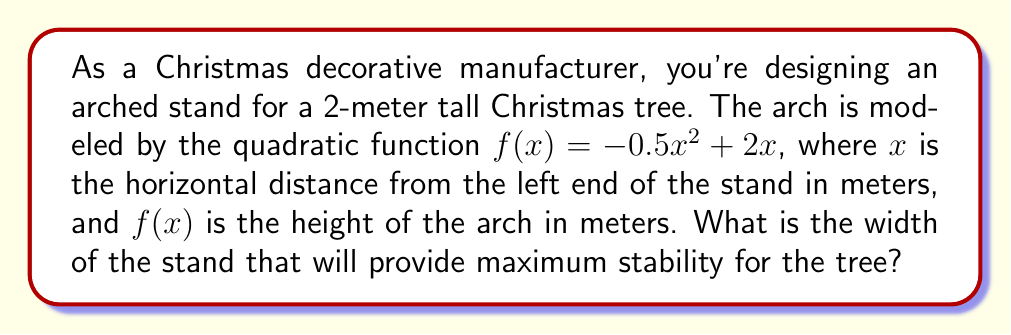Can you answer this question? To find the width of the stand for maximum stability, we need to determine the x-intercepts of the quadratic function, as these represent the points where the arch meets the ground.

Step 1: Set up the equation for x-intercepts
$f(x) = 0$
$-0.5x^2 + 2x = 0$

Step 2: Factor out the common factor
$x(-0.5x + 2) = 0$

Step 3: Solve for x
$x = 0$ or $-0.5x + 2 = 0$
$x = 0$ or $x = 4$

Step 4: Interpret the results
The x-intercepts are at $x = 0$ and $x = 4$. This means the arch touches the ground at these two points.

Step 5: Calculate the width
The width of the stand is the distance between these two points:
$4 - 0 = 4$ meters

Therefore, the width of the stand that will provide maximum stability for the tree is 4 meters.
Answer: 4 meters 